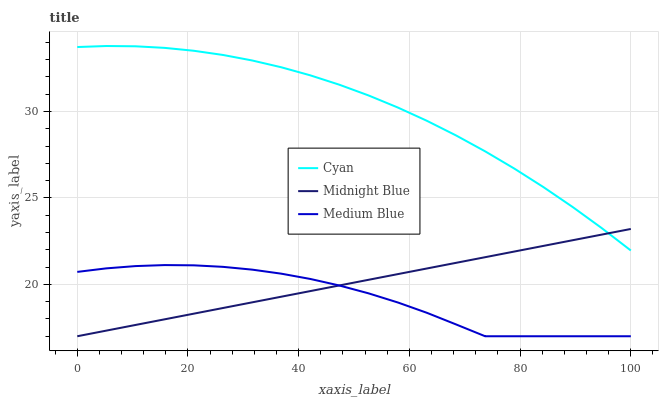Does Medium Blue have the minimum area under the curve?
Answer yes or no. Yes. Does Cyan have the maximum area under the curve?
Answer yes or no. Yes. Does Midnight Blue have the minimum area under the curve?
Answer yes or no. No. Does Midnight Blue have the maximum area under the curve?
Answer yes or no. No. Is Midnight Blue the smoothest?
Answer yes or no. Yes. Is Medium Blue the roughest?
Answer yes or no. Yes. Is Medium Blue the smoothest?
Answer yes or no. No. Is Midnight Blue the roughest?
Answer yes or no. No. Does Medium Blue have the lowest value?
Answer yes or no. Yes. Does Cyan have the highest value?
Answer yes or no. Yes. Does Midnight Blue have the highest value?
Answer yes or no. No. Is Medium Blue less than Cyan?
Answer yes or no. Yes. Is Cyan greater than Medium Blue?
Answer yes or no. Yes. Does Midnight Blue intersect Cyan?
Answer yes or no. Yes. Is Midnight Blue less than Cyan?
Answer yes or no. No. Is Midnight Blue greater than Cyan?
Answer yes or no. No. Does Medium Blue intersect Cyan?
Answer yes or no. No. 